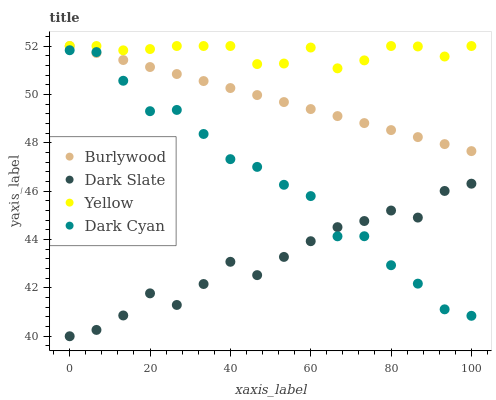Does Dark Slate have the minimum area under the curve?
Answer yes or no. Yes. Does Yellow have the maximum area under the curve?
Answer yes or no. Yes. Does Dark Cyan have the minimum area under the curve?
Answer yes or no. No. Does Dark Cyan have the maximum area under the curve?
Answer yes or no. No. Is Burlywood the smoothest?
Answer yes or no. Yes. Is Dark Cyan the roughest?
Answer yes or no. Yes. Is Dark Slate the smoothest?
Answer yes or no. No. Is Dark Slate the roughest?
Answer yes or no. No. Does Dark Slate have the lowest value?
Answer yes or no. Yes. Does Dark Cyan have the lowest value?
Answer yes or no. No. Does Yellow have the highest value?
Answer yes or no. Yes. Does Dark Cyan have the highest value?
Answer yes or no. No. Is Dark Slate less than Yellow?
Answer yes or no. Yes. Is Burlywood greater than Dark Slate?
Answer yes or no. Yes. Does Burlywood intersect Dark Cyan?
Answer yes or no. Yes. Is Burlywood less than Dark Cyan?
Answer yes or no. No. Is Burlywood greater than Dark Cyan?
Answer yes or no. No. Does Dark Slate intersect Yellow?
Answer yes or no. No. 